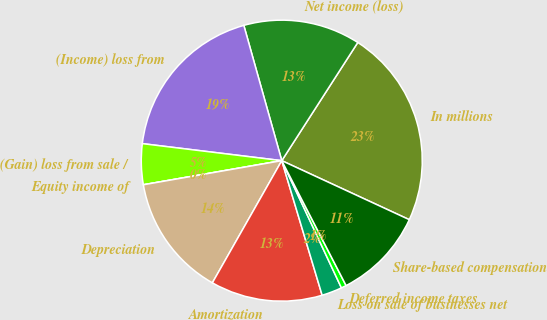Convert chart. <chart><loc_0><loc_0><loc_500><loc_500><pie_chart><fcel>In millions<fcel>Net income (loss)<fcel>(Income) loss from<fcel>(Gain) loss from sale /<fcel>Equity income of<fcel>Depreciation<fcel>Amortization<fcel>Loss on sale of businesses net<fcel>Deferred income taxes<fcel>Share-based compensation<nl><fcel>22.8%<fcel>13.45%<fcel>18.71%<fcel>4.68%<fcel>0.0%<fcel>14.03%<fcel>12.86%<fcel>2.34%<fcel>0.59%<fcel>10.53%<nl></chart> 